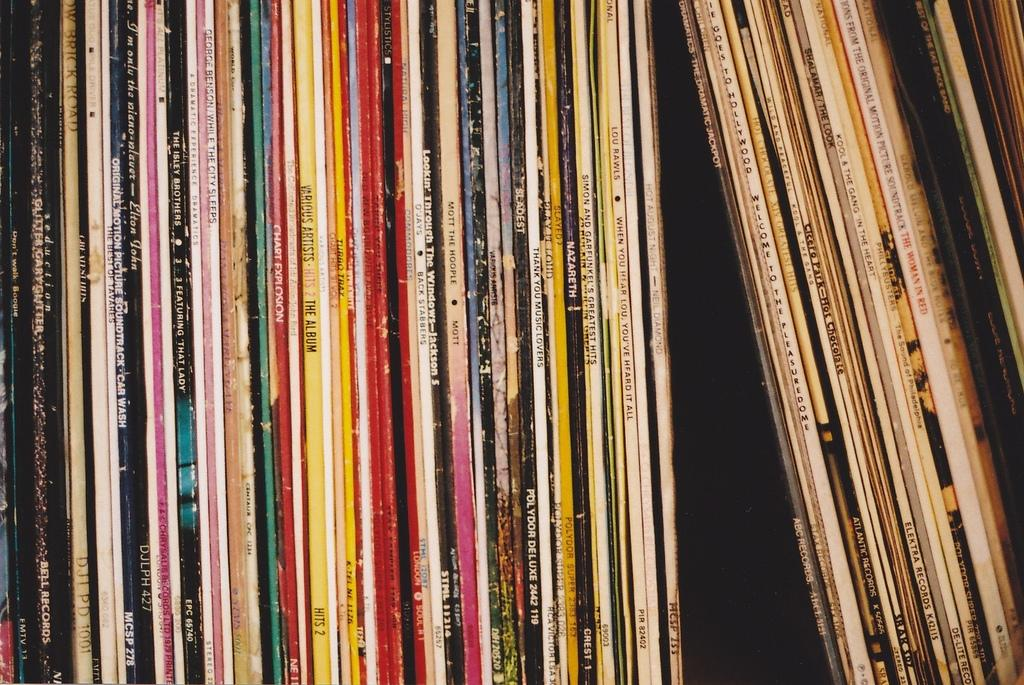Provide a one-sentence caption for the provided image. a collection of old albums from such artists as NAZARETH, The Isley Brothers, Kool & the Gang, etc. 